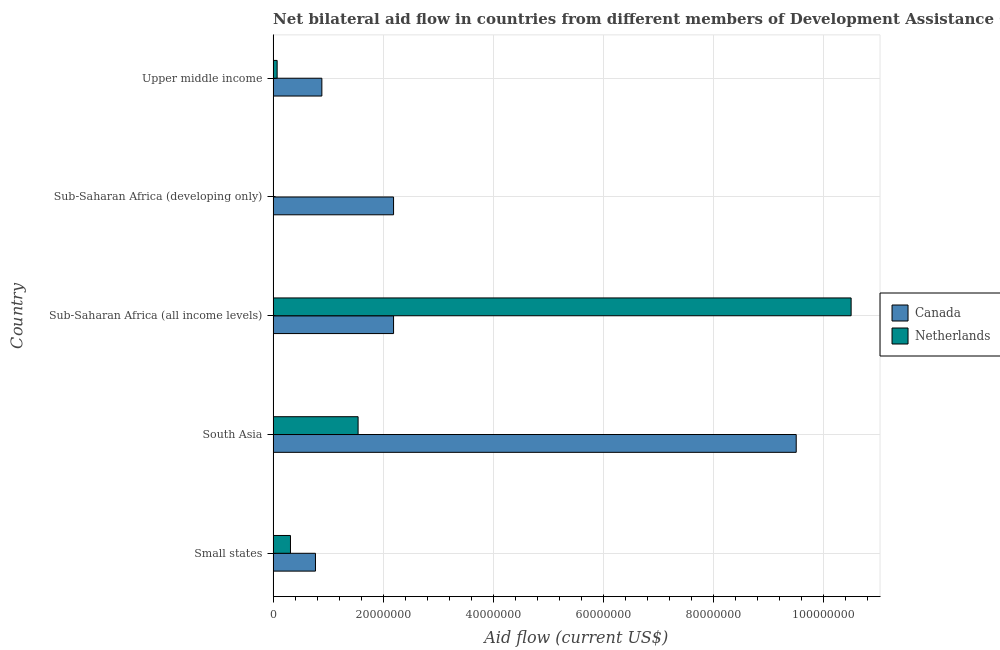How many groups of bars are there?
Give a very brief answer. 5. How many bars are there on the 1st tick from the bottom?
Your response must be concise. 2. What is the label of the 5th group of bars from the top?
Your answer should be very brief. Small states. In how many cases, is the number of bars for a given country not equal to the number of legend labels?
Keep it short and to the point. 0. What is the amount of aid given by canada in South Asia?
Give a very brief answer. 9.50e+07. Across all countries, what is the maximum amount of aid given by netherlands?
Offer a very short reply. 1.05e+08. Across all countries, what is the minimum amount of aid given by netherlands?
Make the answer very short. 10000. In which country was the amount of aid given by netherlands maximum?
Give a very brief answer. Sub-Saharan Africa (all income levels). In which country was the amount of aid given by netherlands minimum?
Offer a terse response. Sub-Saharan Africa (developing only). What is the total amount of aid given by netherlands in the graph?
Offer a terse response. 1.24e+08. What is the difference between the amount of aid given by netherlands in Sub-Saharan Africa (developing only) and that in Upper middle income?
Keep it short and to the point. -7.20e+05. What is the difference between the amount of aid given by canada in Sub-Saharan Africa (all income levels) and the amount of aid given by netherlands in Sub-Saharan Africa (developing only)?
Your answer should be compact. 2.19e+07. What is the average amount of aid given by canada per country?
Provide a short and direct response. 3.11e+07. What is the difference between the amount of aid given by canada and amount of aid given by netherlands in Upper middle income?
Give a very brief answer. 8.12e+06. In how many countries, is the amount of aid given by netherlands greater than 36000000 US$?
Your response must be concise. 1. What is the ratio of the amount of aid given by canada in Sub-Saharan Africa (developing only) to that in Upper middle income?
Provide a succinct answer. 2.47. What is the difference between the highest and the second highest amount of aid given by netherlands?
Offer a very short reply. 8.95e+07. What is the difference between the highest and the lowest amount of aid given by netherlands?
Offer a very short reply. 1.05e+08. In how many countries, is the amount of aid given by canada greater than the average amount of aid given by canada taken over all countries?
Your answer should be very brief. 1. What does the 1st bar from the bottom in Sub-Saharan Africa (developing only) represents?
Offer a terse response. Canada. Are all the bars in the graph horizontal?
Your response must be concise. Yes. Are the values on the major ticks of X-axis written in scientific E-notation?
Provide a succinct answer. No. Does the graph contain any zero values?
Provide a succinct answer. No. Does the graph contain grids?
Your response must be concise. Yes. Where does the legend appear in the graph?
Give a very brief answer. Center right. How many legend labels are there?
Provide a succinct answer. 2. How are the legend labels stacked?
Your answer should be very brief. Vertical. What is the title of the graph?
Your answer should be very brief. Net bilateral aid flow in countries from different members of Development Assistance Committee. Does "Primary school" appear as one of the legend labels in the graph?
Make the answer very short. No. What is the label or title of the X-axis?
Your answer should be compact. Aid flow (current US$). What is the Aid flow (current US$) of Canada in Small states?
Ensure brevity in your answer.  7.69e+06. What is the Aid flow (current US$) in Netherlands in Small states?
Ensure brevity in your answer.  3.15e+06. What is the Aid flow (current US$) in Canada in South Asia?
Your answer should be compact. 9.50e+07. What is the Aid flow (current US$) of Netherlands in South Asia?
Keep it short and to the point. 1.54e+07. What is the Aid flow (current US$) of Canada in Sub-Saharan Africa (all income levels)?
Provide a succinct answer. 2.19e+07. What is the Aid flow (current US$) in Netherlands in Sub-Saharan Africa (all income levels)?
Offer a terse response. 1.05e+08. What is the Aid flow (current US$) of Canada in Sub-Saharan Africa (developing only)?
Offer a very short reply. 2.19e+07. What is the Aid flow (current US$) of Canada in Upper middle income?
Make the answer very short. 8.85e+06. What is the Aid flow (current US$) in Netherlands in Upper middle income?
Keep it short and to the point. 7.30e+05. Across all countries, what is the maximum Aid flow (current US$) in Canada?
Give a very brief answer. 9.50e+07. Across all countries, what is the maximum Aid flow (current US$) in Netherlands?
Your answer should be very brief. 1.05e+08. Across all countries, what is the minimum Aid flow (current US$) in Canada?
Provide a short and direct response. 7.69e+06. What is the total Aid flow (current US$) of Canada in the graph?
Your answer should be very brief. 1.55e+08. What is the total Aid flow (current US$) of Netherlands in the graph?
Give a very brief answer. 1.24e+08. What is the difference between the Aid flow (current US$) in Canada in Small states and that in South Asia?
Give a very brief answer. -8.73e+07. What is the difference between the Aid flow (current US$) of Netherlands in Small states and that in South Asia?
Provide a succinct answer. -1.23e+07. What is the difference between the Aid flow (current US$) of Canada in Small states and that in Sub-Saharan Africa (all income levels)?
Keep it short and to the point. -1.42e+07. What is the difference between the Aid flow (current US$) in Netherlands in Small states and that in Sub-Saharan Africa (all income levels)?
Offer a very short reply. -1.02e+08. What is the difference between the Aid flow (current US$) in Canada in Small states and that in Sub-Saharan Africa (developing only)?
Keep it short and to the point. -1.42e+07. What is the difference between the Aid flow (current US$) of Netherlands in Small states and that in Sub-Saharan Africa (developing only)?
Your answer should be very brief. 3.14e+06. What is the difference between the Aid flow (current US$) of Canada in Small states and that in Upper middle income?
Offer a terse response. -1.16e+06. What is the difference between the Aid flow (current US$) in Netherlands in Small states and that in Upper middle income?
Provide a short and direct response. 2.42e+06. What is the difference between the Aid flow (current US$) of Canada in South Asia and that in Sub-Saharan Africa (all income levels)?
Keep it short and to the point. 7.31e+07. What is the difference between the Aid flow (current US$) of Netherlands in South Asia and that in Sub-Saharan Africa (all income levels)?
Ensure brevity in your answer.  -8.95e+07. What is the difference between the Aid flow (current US$) of Canada in South Asia and that in Sub-Saharan Africa (developing only)?
Your answer should be compact. 7.31e+07. What is the difference between the Aid flow (current US$) in Netherlands in South Asia and that in Sub-Saharan Africa (developing only)?
Offer a very short reply. 1.54e+07. What is the difference between the Aid flow (current US$) of Canada in South Asia and that in Upper middle income?
Ensure brevity in your answer.  8.61e+07. What is the difference between the Aid flow (current US$) in Netherlands in South Asia and that in Upper middle income?
Offer a very short reply. 1.47e+07. What is the difference between the Aid flow (current US$) in Canada in Sub-Saharan Africa (all income levels) and that in Sub-Saharan Africa (developing only)?
Your answer should be very brief. 0. What is the difference between the Aid flow (current US$) of Netherlands in Sub-Saharan Africa (all income levels) and that in Sub-Saharan Africa (developing only)?
Ensure brevity in your answer.  1.05e+08. What is the difference between the Aid flow (current US$) in Canada in Sub-Saharan Africa (all income levels) and that in Upper middle income?
Make the answer very short. 1.30e+07. What is the difference between the Aid flow (current US$) in Netherlands in Sub-Saharan Africa (all income levels) and that in Upper middle income?
Your answer should be very brief. 1.04e+08. What is the difference between the Aid flow (current US$) of Canada in Sub-Saharan Africa (developing only) and that in Upper middle income?
Your answer should be very brief. 1.30e+07. What is the difference between the Aid flow (current US$) in Netherlands in Sub-Saharan Africa (developing only) and that in Upper middle income?
Offer a terse response. -7.20e+05. What is the difference between the Aid flow (current US$) in Canada in Small states and the Aid flow (current US$) in Netherlands in South Asia?
Your answer should be compact. -7.74e+06. What is the difference between the Aid flow (current US$) of Canada in Small states and the Aid flow (current US$) of Netherlands in Sub-Saharan Africa (all income levels)?
Give a very brief answer. -9.73e+07. What is the difference between the Aid flow (current US$) in Canada in Small states and the Aid flow (current US$) in Netherlands in Sub-Saharan Africa (developing only)?
Your response must be concise. 7.68e+06. What is the difference between the Aid flow (current US$) in Canada in Small states and the Aid flow (current US$) in Netherlands in Upper middle income?
Provide a succinct answer. 6.96e+06. What is the difference between the Aid flow (current US$) of Canada in South Asia and the Aid flow (current US$) of Netherlands in Sub-Saharan Africa (all income levels)?
Your answer should be very brief. -9.97e+06. What is the difference between the Aid flow (current US$) of Canada in South Asia and the Aid flow (current US$) of Netherlands in Sub-Saharan Africa (developing only)?
Provide a succinct answer. 9.50e+07. What is the difference between the Aid flow (current US$) in Canada in South Asia and the Aid flow (current US$) in Netherlands in Upper middle income?
Your response must be concise. 9.42e+07. What is the difference between the Aid flow (current US$) of Canada in Sub-Saharan Africa (all income levels) and the Aid flow (current US$) of Netherlands in Sub-Saharan Africa (developing only)?
Provide a succinct answer. 2.19e+07. What is the difference between the Aid flow (current US$) of Canada in Sub-Saharan Africa (all income levels) and the Aid flow (current US$) of Netherlands in Upper middle income?
Give a very brief answer. 2.11e+07. What is the difference between the Aid flow (current US$) in Canada in Sub-Saharan Africa (developing only) and the Aid flow (current US$) in Netherlands in Upper middle income?
Your response must be concise. 2.11e+07. What is the average Aid flow (current US$) of Canada per country?
Provide a succinct answer. 3.11e+07. What is the average Aid flow (current US$) of Netherlands per country?
Provide a short and direct response. 2.49e+07. What is the difference between the Aid flow (current US$) in Canada and Aid flow (current US$) in Netherlands in Small states?
Offer a terse response. 4.54e+06. What is the difference between the Aid flow (current US$) of Canada and Aid flow (current US$) of Netherlands in South Asia?
Offer a very short reply. 7.96e+07. What is the difference between the Aid flow (current US$) in Canada and Aid flow (current US$) in Netherlands in Sub-Saharan Africa (all income levels)?
Offer a very short reply. -8.31e+07. What is the difference between the Aid flow (current US$) of Canada and Aid flow (current US$) of Netherlands in Sub-Saharan Africa (developing only)?
Give a very brief answer. 2.19e+07. What is the difference between the Aid flow (current US$) in Canada and Aid flow (current US$) in Netherlands in Upper middle income?
Give a very brief answer. 8.12e+06. What is the ratio of the Aid flow (current US$) of Canada in Small states to that in South Asia?
Ensure brevity in your answer.  0.08. What is the ratio of the Aid flow (current US$) in Netherlands in Small states to that in South Asia?
Give a very brief answer. 0.2. What is the ratio of the Aid flow (current US$) of Canada in Small states to that in Sub-Saharan Africa (all income levels)?
Provide a short and direct response. 0.35. What is the ratio of the Aid flow (current US$) in Canada in Small states to that in Sub-Saharan Africa (developing only)?
Make the answer very short. 0.35. What is the ratio of the Aid flow (current US$) in Netherlands in Small states to that in Sub-Saharan Africa (developing only)?
Keep it short and to the point. 315. What is the ratio of the Aid flow (current US$) of Canada in Small states to that in Upper middle income?
Provide a short and direct response. 0.87. What is the ratio of the Aid flow (current US$) in Netherlands in Small states to that in Upper middle income?
Your answer should be compact. 4.32. What is the ratio of the Aid flow (current US$) in Canada in South Asia to that in Sub-Saharan Africa (all income levels)?
Provide a succinct answer. 4.34. What is the ratio of the Aid flow (current US$) in Netherlands in South Asia to that in Sub-Saharan Africa (all income levels)?
Your answer should be compact. 0.15. What is the ratio of the Aid flow (current US$) of Canada in South Asia to that in Sub-Saharan Africa (developing only)?
Keep it short and to the point. 4.34. What is the ratio of the Aid flow (current US$) in Netherlands in South Asia to that in Sub-Saharan Africa (developing only)?
Offer a terse response. 1543. What is the ratio of the Aid flow (current US$) of Canada in South Asia to that in Upper middle income?
Provide a succinct answer. 10.73. What is the ratio of the Aid flow (current US$) of Netherlands in South Asia to that in Upper middle income?
Your answer should be very brief. 21.14. What is the ratio of the Aid flow (current US$) of Netherlands in Sub-Saharan Africa (all income levels) to that in Sub-Saharan Africa (developing only)?
Offer a terse response. 1.05e+04. What is the ratio of the Aid flow (current US$) in Canada in Sub-Saharan Africa (all income levels) to that in Upper middle income?
Your answer should be compact. 2.47. What is the ratio of the Aid flow (current US$) of Netherlands in Sub-Saharan Africa (all income levels) to that in Upper middle income?
Keep it short and to the point. 143.77. What is the ratio of the Aid flow (current US$) in Canada in Sub-Saharan Africa (developing only) to that in Upper middle income?
Provide a short and direct response. 2.47. What is the ratio of the Aid flow (current US$) of Netherlands in Sub-Saharan Africa (developing only) to that in Upper middle income?
Your answer should be very brief. 0.01. What is the difference between the highest and the second highest Aid flow (current US$) in Canada?
Your response must be concise. 7.31e+07. What is the difference between the highest and the second highest Aid flow (current US$) of Netherlands?
Your response must be concise. 8.95e+07. What is the difference between the highest and the lowest Aid flow (current US$) in Canada?
Your answer should be very brief. 8.73e+07. What is the difference between the highest and the lowest Aid flow (current US$) in Netherlands?
Ensure brevity in your answer.  1.05e+08. 